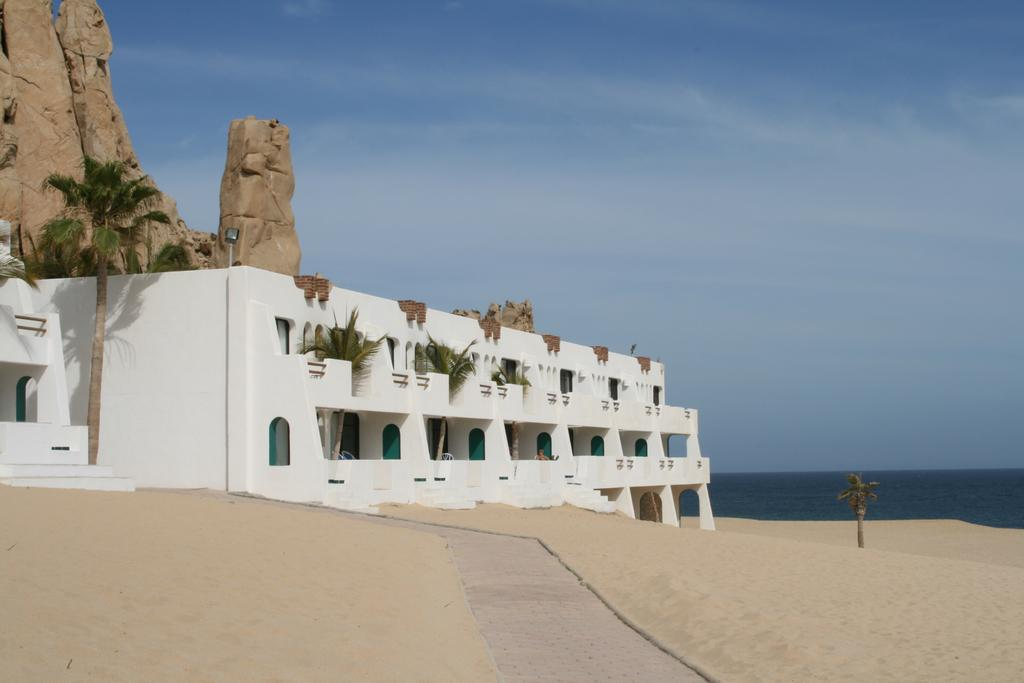What type of terrain is visible in the image? There is sand in the image. What kind of feature can be seen in the image that might be used for walking? There is a path in the image. What type of vegetation is present in the image? There are trees in the image. What type of structure can be seen in the image? There is a white building in the image. What can be seen in the distance in the image? There is a mountain and water visible in the background of the image, as well as the sky. What type of record can be seen spinning on a turntable in the image? There is no record or turntable present in the image. Can you see any cows grazing in the image? There are no cows present in the image. 